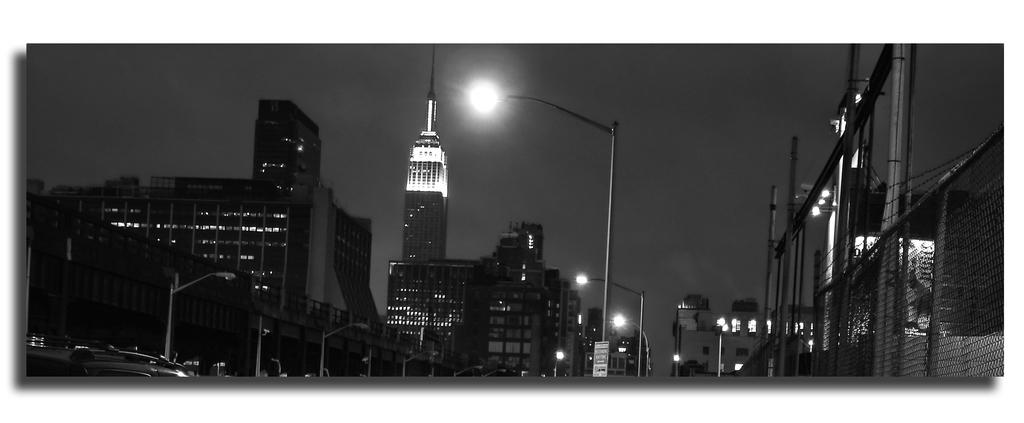What is the color scheme of the image? The image is black and white. What type of structures can be seen in the image? There are tower buildings in the image. What are the light sources in the image? There are light poles in the image. What type of transportation is present in the image? There are vehicles in the image. What type of barrier is present in the image? There is a fence in the image. What celestial body is visible in the image? The moon is visible in the image. Can you tell me how many people are walking in the image? There are no people visible in the image, so it is not possible to determine how many are walking. What type of approval is required for the construction of the tower buildings in the image? The image does not provide information about the construction or approval process for the tower buildings. 